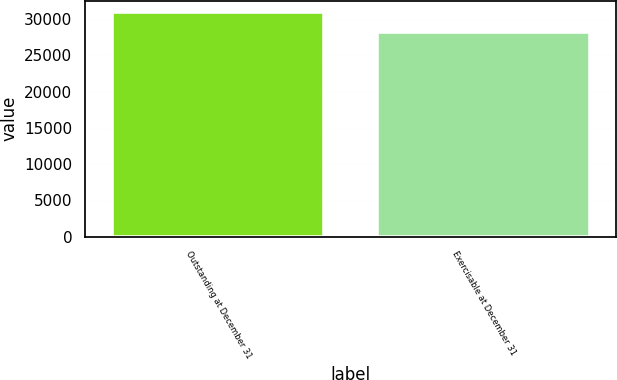Convert chart. <chart><loc_0><loc_0><loc_500><loc_500><bar_chart><fcel>Outstanding at December 31<fcel>Exercisable at December 31<nl><fcel>31002<fcel>28172<nl></chart> 